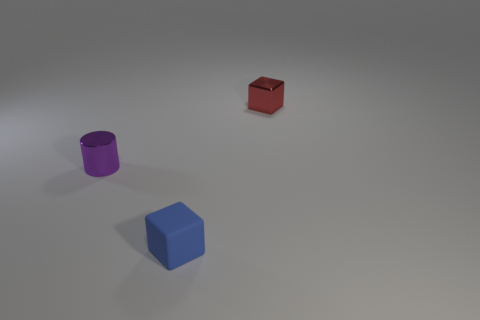Add 2 tiny shiny cylinders. How many objects exist? 5 Subtract all cubes. How many objects are left? 1 Subtract all red cubes. How many cubes are left? 1 Subtract all gray things. Subtract all small blue rubber blocks. How many objects are left? 2 Add 1 rubber things. How many rubber things are left? 2 Add 3 purple cylinders. How many purple cylinders exist? 4 Subtract 0 green blocks. How many objects are left? 3 Subtract 2 cubes. How many cubes are left? 0 Subtract all brown cubes. Subtract all yellow cylinders. How many cubes are left? 2 Subtract all green cylinders. How many purple blocks are left? 0 